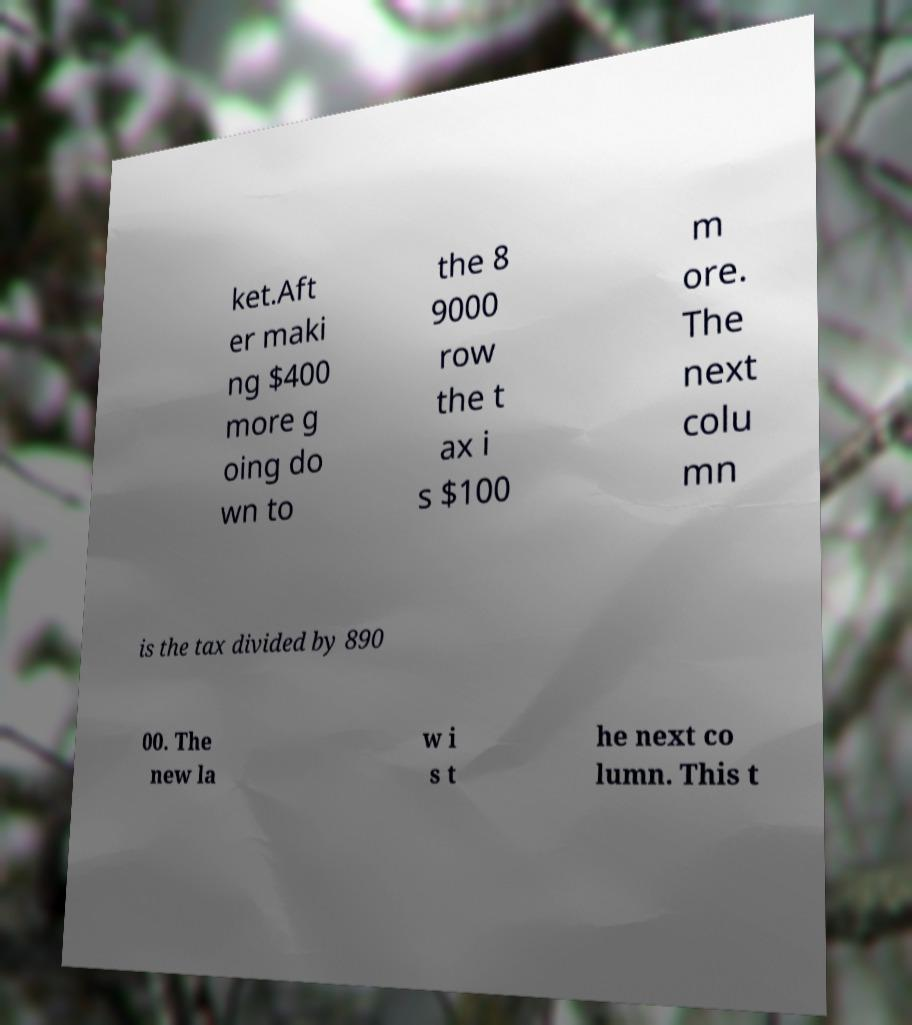There's text embedded in this image that I need extracted. Can you transcribe it verbatim? ket.Aft er maki ng $400 more g oing do wn to the 8 9000 row the t ax i s $100 m ore. The next colu mn is the tax divided by 890 00. The new la w i s t he next co lumn. This t 